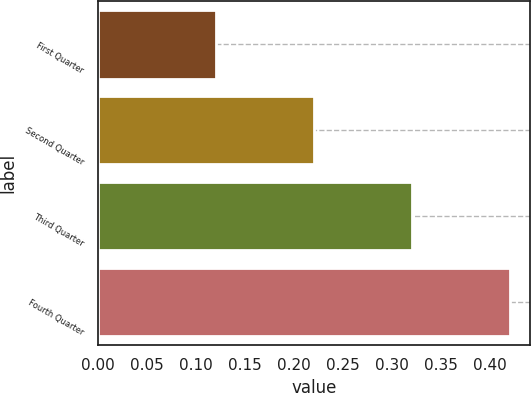Convert chart to OTSL. <chart><loc_0><loc_0><loc_500><loc_500><bar_chart><fcel>First Quarter<fcel>Second Quarter<fcel>Third Quarter<fcel>Fourth Quarter<nl><fcel>0.12<fcel>0.22<fcel>0.32<fcel>0.42<nl></chart> 